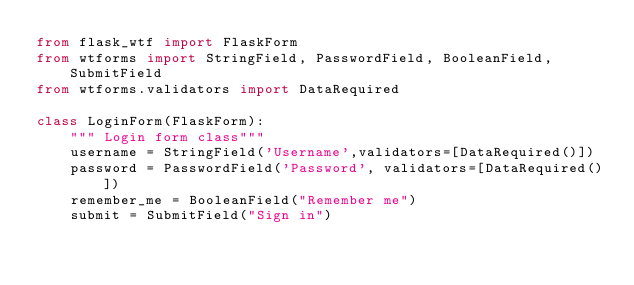Convert code to text. <code><loc_0><loc_0><loc_500><loc_500><_Python_>from flask_wtf import FlaskForm
from wtforms import StringField, PasswordField, BooleanField, SubmitField
from wtforms.validators import DataRequired

class LoginForm(FlaskForm):
    """ Login form class"""
    username = StringField('Username',validators=[DataRequired()])
    password = PasswordField('Password', validators=[DataRequired()])
    remember_me = BooleanField("Remember me")
    submit = SubmitField("Sign in")</code> 